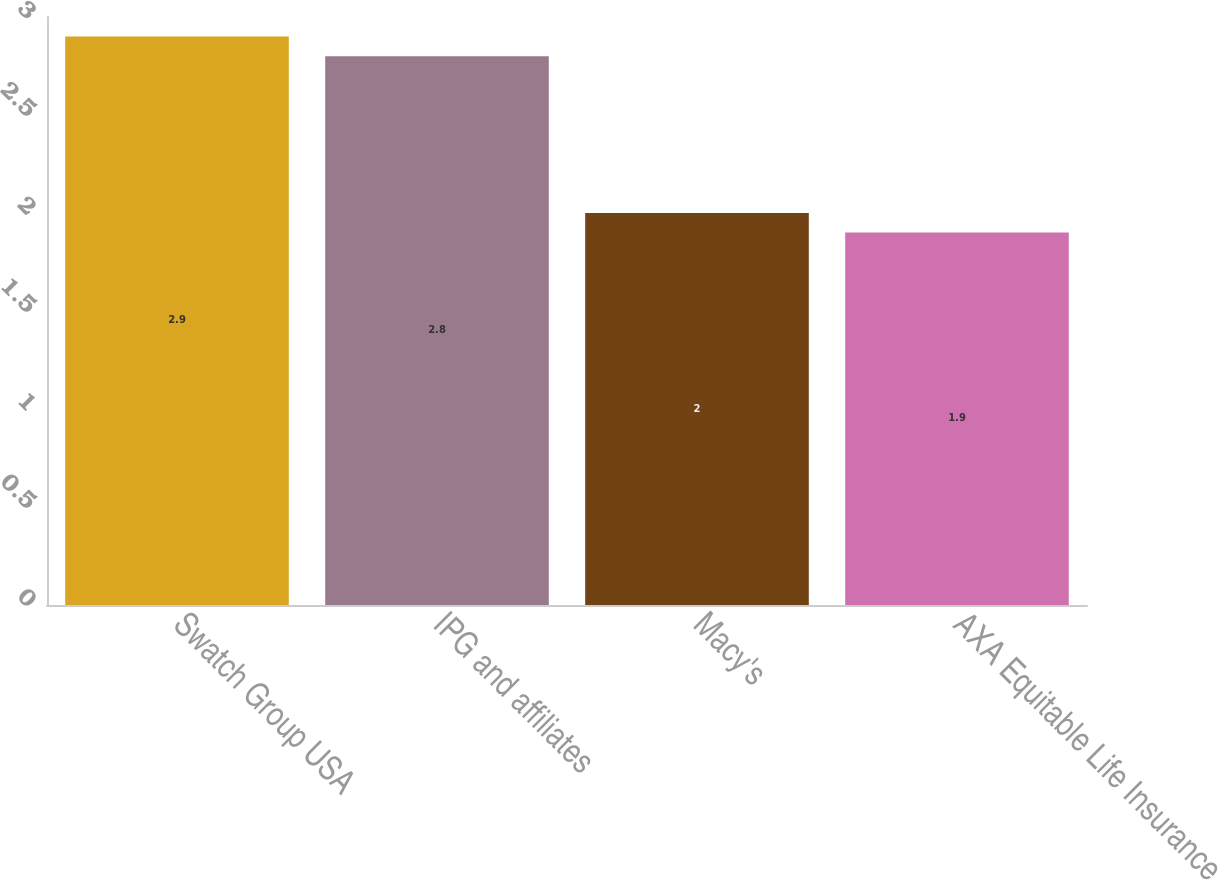Convert chart to OTSL. <chart><loc_0><loc_0><loc_500><loc_500><bar_chart><fcel>Swatch Group USA<fcel>IPG and affiliates<fcel>Macy's<fcel>AXA Equitable Life Insurance<nl><fcel>2.9<fcel>2.8<fcel>2<fcel>1.9<nl></chart> 